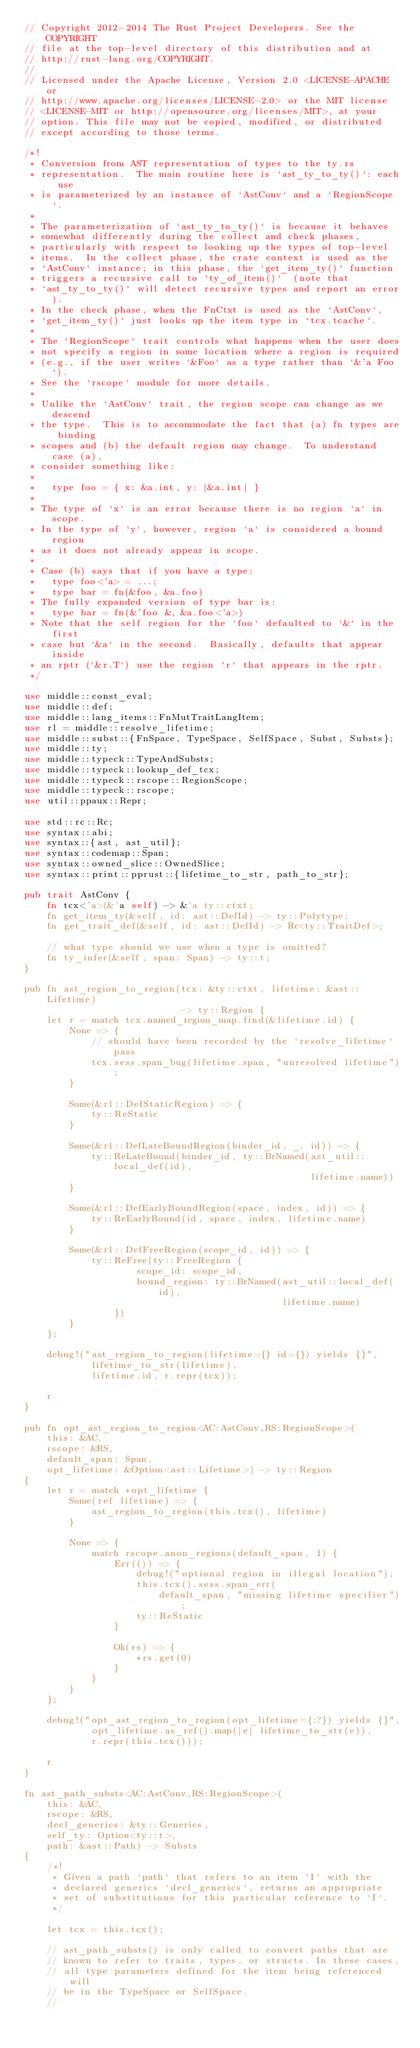<code> <loc_0><loc_0><loc_500><loc_500><_Rust_>// Copyright 2012-2014 The Rust Project Developers. See the COPYRIGHT
// file at the top-level directory of this distribution and at
// http://rust-lang.org/COPYRIGHT.
//
// Licensed under the Apache License, Version 2.0 <LICENSE-APACHE or
// http://www.apache.org/licenses/LICENSE-2.0> or the MIT license
// <LICENSE-MIT or http://opensource.org/licenses/MIT>, at your
// option. This file may not be copied, modified, or distributed
// except according to those terms.

/*!
 * Conversion from AST representation of types to the ty.rs
 * representation.  The main routine here is `ast_ty_to_ty()`: each use
 * is parameterized by an instance of `AstConv` and a `RegionScope`.
 *
 * The parameterization of `ast_ty_to_ty()` is because it behaves
 * somewhat differently during the collect and check phases,
 * particularly with respect to looking up the types of top-level
 * items.  In the collect phase, the crate context is used as the
 * `AstConv` instance; in this phase, the `get_item_ty()` function
 * triggers a recursive call to `ty_of_item()`  (note that
 * `ast_ty_to_ty()` will detect recursive types and report an error).
 * In the check phase, when the FnCtxt is used as the `AstConv`,
 * `get_item_ty()` just looks up the item type in `tcx.tcache`.
 *
 * The `RegionScope` trait controls what happens when the user does
 * not specify a region in some location where a region is required
 * (e.g., if the user writes `&Foo` as a type rather than `&'a Foo`).
 * See the `rscope` module for more details.
 *
 * Unlike the `AstConv` trait, the region scope can change as we descend
 * the type.  This is to accommodate the fact that (a) fn types are binding
 * scopes and (b) the default region may change.  To understand case (a),
 * consider something like:
 *
 *   type foo = { x: &a.int, y: |&a.int| }
 *
 * The type of `x` is an error because there is no region `a` in scope.
 * In the type of `y`, however, region `a` is considered a bound region
 * as it does not already appear in scope.
 *
 * Case (b) says that if you have a type:
 *   type foo<'a> = ...;
 *   type bar = fn(&foo, &a.foo)
 * The fully expanded version of type bar is:
 *   type bar = fn(&'foo &, &a.foo<'a>)
 * Note that the self region for the `foo` defaulted to `&` in the first
 * case but `&a` in the second.  Basically, defaults that appear inside
 * an rptr (`&r.T`) use the region `r` that appears in the rptr.
 */

use middle::const_eval;
use middle::def;
use middle::lang_items::FnMutTraitLangItem;
use rl = middle::resolve_lifetime;
use middle::subst::{FnSpace, TypeSpace, SelfSpace, Subst, Substs};
use middle::ty;
use middle::typeck::TypeAndSubsts;
use middle::typeck::lookup_def_tcx;
use middle::typeck::rscope::RegionScope;
use middle::typeck::rscope;
use util::ppaux::Repr;

use std::rc::Rc;
use syntax::abi;
use syntax::{ast, ast_util};
use syntax::codemap::Span;
use syntax::owned_slice::OwnedSlice;
use syntax::print::pprust::{lifetime_to_str, path_to_str};

pub trait AstConv {
    fn tcx<'a>(&'a self) -> &'a ty::ctxt;
    fn get_item_ty(&self, id: ast::DefId) -> ty::Polytype;
    fn get_trait_def(&self, id: ast::DefId) -> Rc<ty::TraitDef>;

    // what type should we use when a type is omitted?
    fn ty_infer(&self, span: Span) -> ty::t;
}

pub fn ast_region_to_region(tcx: &ty::ctxt, lifetime: &ast::Lifetime)
                            -> ty::Region {
    let r = match tcx.named_region_map.find(&lifetime.id) {
        None => {
            // should have been recorded by the `resolve_lifetime` pass
            tcx.sess.span_bug(lifetime.span, "unresolved lifetime");
        }

        Some(&rl::DefStaticRegion) => {
            ty::ReStatic
        }

        Some(&rl::DefLateBoundRegion(binder_id, _, id)) => {
            ty::ReLateBound(binder_id, ty::BrNamed(ast_util::local_def(id),
                                                   lifetime.name))
        }

        Some(&rl::DefEarlyBoundRegion(space, index, id)) => {
            ty::ReEarlyBound(id, space, index, lifetime.name)
        }

        Some(&rl::DefFreeRegion(scope_id, id)) => {
            ty::ReFree(ty::FreeRegion {
                    scope_id: scope_id,
                    bound_region: ty::BrNamed(ast_util::local_def(id),
                                              lifetime.name)
                })
        }
    };

    debug!("ast_region_to_region(lifetime={} id={}) yields {}",
            lifetime_to_str(lifetime),
            lifetime.id, r.repr(tcx));

    r
}

pub fn opt_ast_region_to_region<AC:AstConv,RS:RegionScope>(
    this: &AC,
    rscope: &RS,
    default_span: Span,
    opt_lifetime: &Option<ast::Lifetime>) -> ty::Region
{
    let r = match *opt_lifetime {
        Some(ref lifetime) => {
            ast_region_to_region(this.tcx(), lifetime)
        }

        None => {
            match rscope.anon_regions(default_span, 1) {
                Err(()) => {
                    debug!("optional region in illegal location");
                    this.tcx().sess.span_err(
                        default_span, "missing lifetime specifier");
                    ty::ReStatic
                }

                Ok(rs) => {
                    *rs.get(0)
                }
            }
        }
    };

    debug!("opt_ast_region_to_region(opt_lifetime={:?}) yields {}",
            opt_lifetime.as_ref().map(|e| lifetime_to_str(e)),
            r.repr(this.tcx()));

    r
}

fn ast_path_substs<AC:AstConv,RS:RegionScope>(
    this: &AC,
    rscope: &RS,
    decl_generics: &ty::Generics,
    self_ty: Option<ty::t>,
    path: &ast::Path) -> Substs
{
    /*!
     * Given a path `path` that refers to an item `I` with the
     * declared generics `decl_generics`, returns an appropriate
     * set of substitutions for this particular reference to `I`.
     */

    let tcx = this.tcx();

    // ast_path_substs() is only called to convert paths that are
    // known to refer to traits, types, or structs. In these cases,
    // all type parameters defined for the item being referenced will
    // be in the TypeSpace or SelfSpace.
    //</code> 